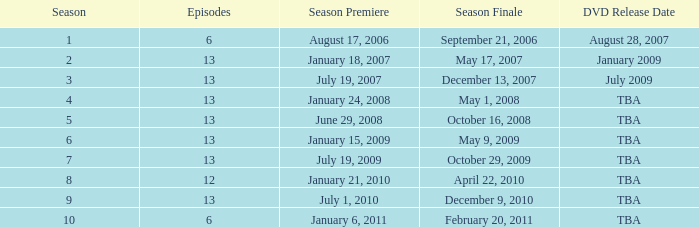What is the release date of the dvd for the season consisting of under 13 episodes that premiered before the 8th season? August 28, 2007. 